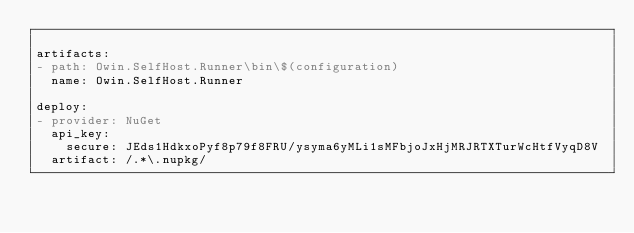Convert code to text. <code><loc_0><loc_0><loc_500><loc_500><_YAML_>
artifacts:
- path: Owin.SelfHost.Runner\bin\$(configuration)
  name: Owin.SelfHost.Runner

deploy:
- provider: NuGet
  api_key:
    secure: JEds1HdkxoPyf8p79f8FRU/ysyma6yMLi1sMFbjoJxHjMRJRTXTurWcHtfVyqD8V
  artifact: /.*\.nupkg/
</code> 